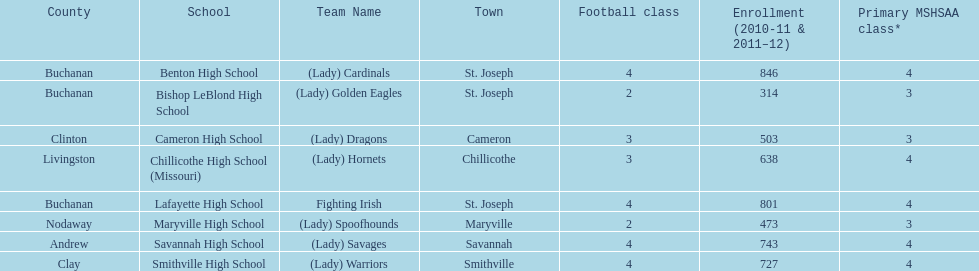What is the lowest number of students enrolled at a school as listed here? 314. What school has 314 students enrolled? Bishop LeBlond High School. 